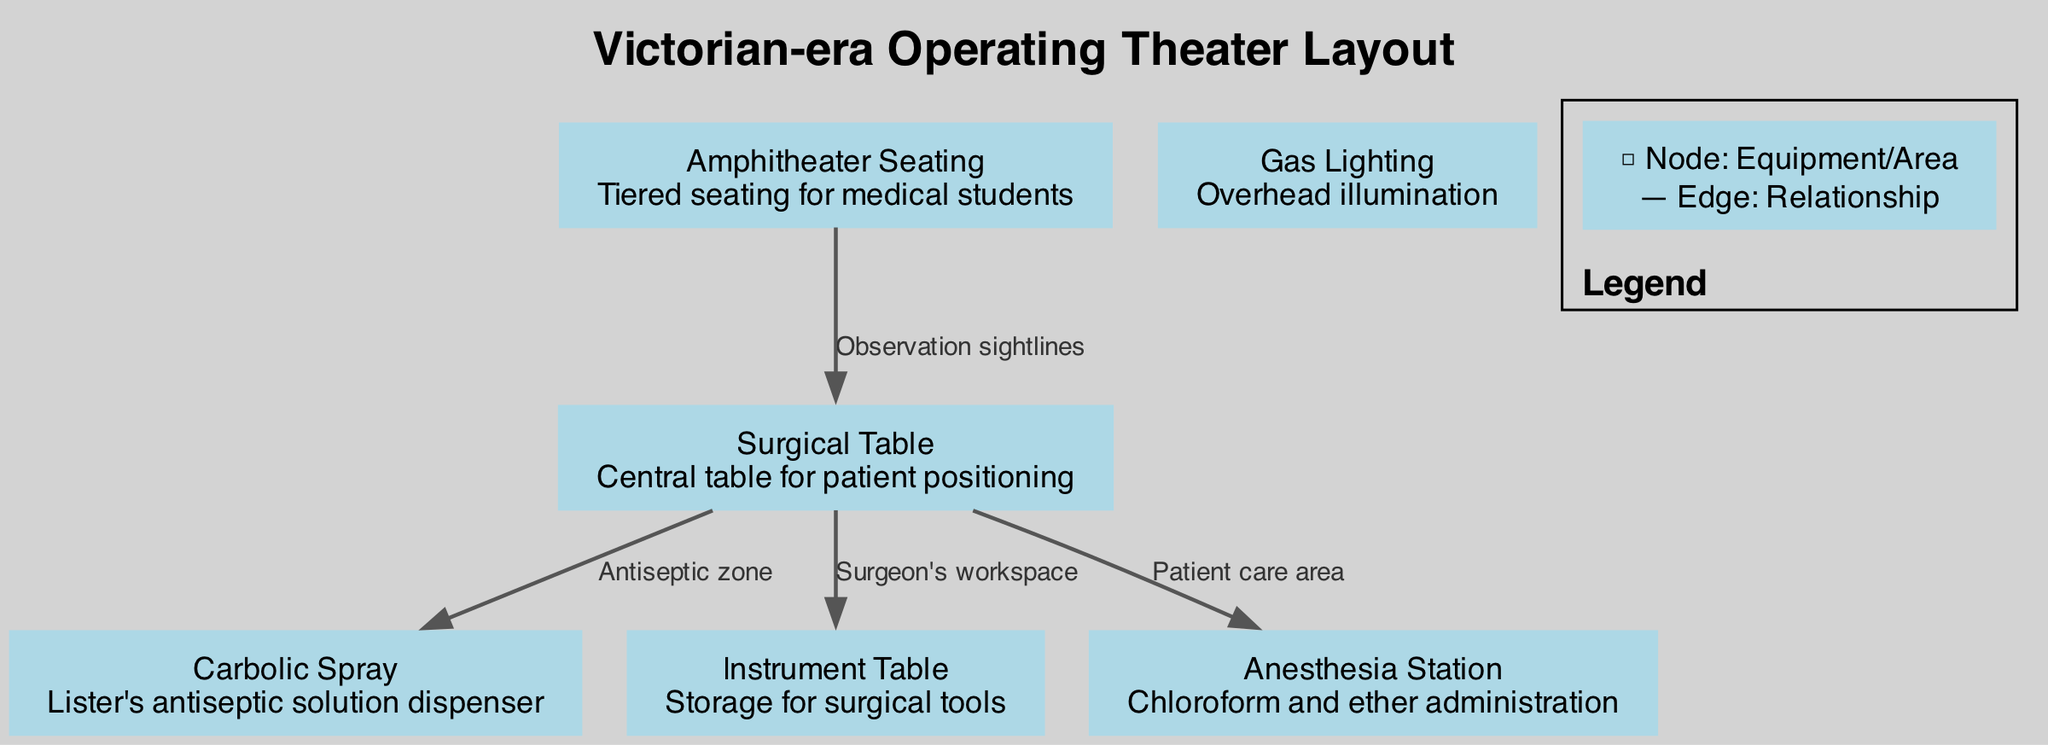What is the central element of the operating theater layout? The central element is the Surgical Table, which is positioned for patient positioning during surgery.
Answer: Surgical Table How many nodes are present in the diagram? The diagram consists of 6 nodes, representing various components of the operating theater layout.
Answer: 6 What is the purpose of the Carbolic Spray? The Carbolic Spray is used as Lister's antiseptic solution dispenser to maintain hygiene during surgeries.
Answer: Lister's antiseptic solution dispenser Which node is directly linked to the Instrument Table? The Surgical Table is directly linked to the Instrument Table, indicating that it serves as the surgeon's workspace where surgical tools are stored.
Answer: Surgical Table What type of seating is provided for medical students? The diagram includes Amphitheater Seating, which consists of tiered seating arranged to provide good visibility for observing surgical procedures.
Answer: Tiered seating How many edges connect the Surgical Table to other nodes? The Surgical Table has 3 edges connecting it to other nodes, which demonstrate its relationships and interactions with various components of the operating theater.
Answer: 3 What is the main source of illumination in the operating theater? The Gas Lighting serves as the main source of overhead illumination, ensuring the room is well-lit for surgical procedures.
Answer: Overhead illumination What does the edge labeled "Antiseptic zone" connect? The edge labeled "Antiseptic zone" connects the Surgical Table to the Carbolic Spray, indicating that this area is designated for antiseptic use.
Answer: Surgical Table and Carbolic Spray Which node has observation sightlines to the Surgical Table? The Amphitheater Seating node has observation sightlines to the Surgical Table, allowing medical students to observe the surgery from the tiered seating.
Answer: Amphitheater Seating 